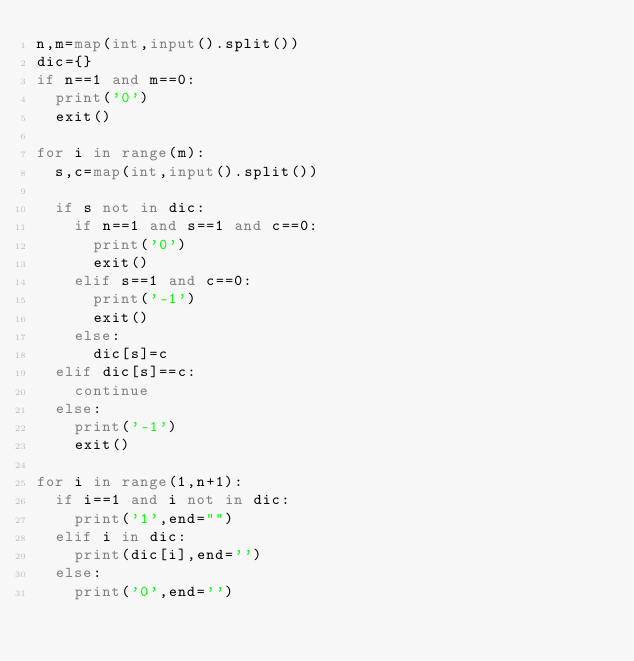Convert code to text. <code><loc_0><loc_0><loc_500><loc_500><_Python_>n,m=map(int,input().split())
dic={}
if n==1 and m==0:
  print('0')
  exit()

for i in range(m):
  s,c=map(int,input().split())
  
  if s not in dic:
    if n==1 and s==1 and c==0:
      print('0')
      exit()
    elif s==1 and c==0:
      print('-1')
      exit()
    else:
      dic[s]=c
  elif dic[s]==c:
    continue
  else:
    print('-1')
    exit()

for i in range(1,n+1):
  if i==1 and i not in dic:
    print('1',end="")
  elif i in dic:
    print(dic[i],end='')
  else:
    print('0',end='')
</code> 